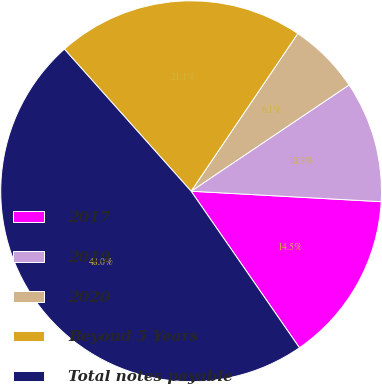Convert chart. <chart><loc_0><loc_0><loc_500><loc_500><pie_chart><fcel>2017<fcel>2019<fcel>2020<fcel>Beyond 5 Years<fcel>Total notes payable<nl><fcel>14.49%<fcel>10.3%<fcel>6.11%<fcel>21.06%<fcel>48.04%<nl></chart> 